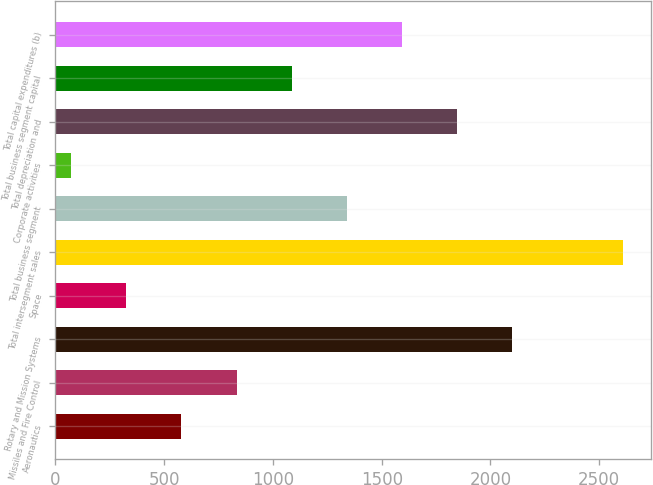<chart> <loc_0><loc_0><loc_500><loc_500><bar_chart><fcel>Aeronautics<fcel>Missiles and Fire Control<fcel>Rotary and Mission Systems<fcel>Space<fcel>Total intersegment sales<fcel>Total business segment<fcel>Corporate activities<fcel>Total depreciation and<fcel>Total business segment capital<fcel>Total capital expenditures (b)<nl><fcel>579.2<fcel>832.8<fcel>2100.8<fcel>325.6<fcel>2608<fcel>1340<fcel>72<fcel>1847.2<fcel>1086.4<fcel>1593.6<nl></chart> 